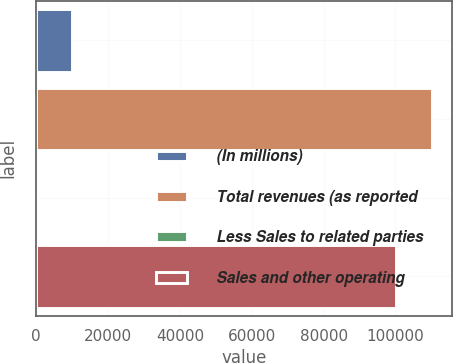Convert chart. <chart><loc_0><loc_0><loc_500><loc_500><bar_chart><fcel>(In millions)<fcel>Total revenues (as reported<fcel>Less Sales to related parties<fcel>Sales and other operating<nl><fcel>10023.8<fcel>110168<fcel>8<fcel>100152<nl></chart> 